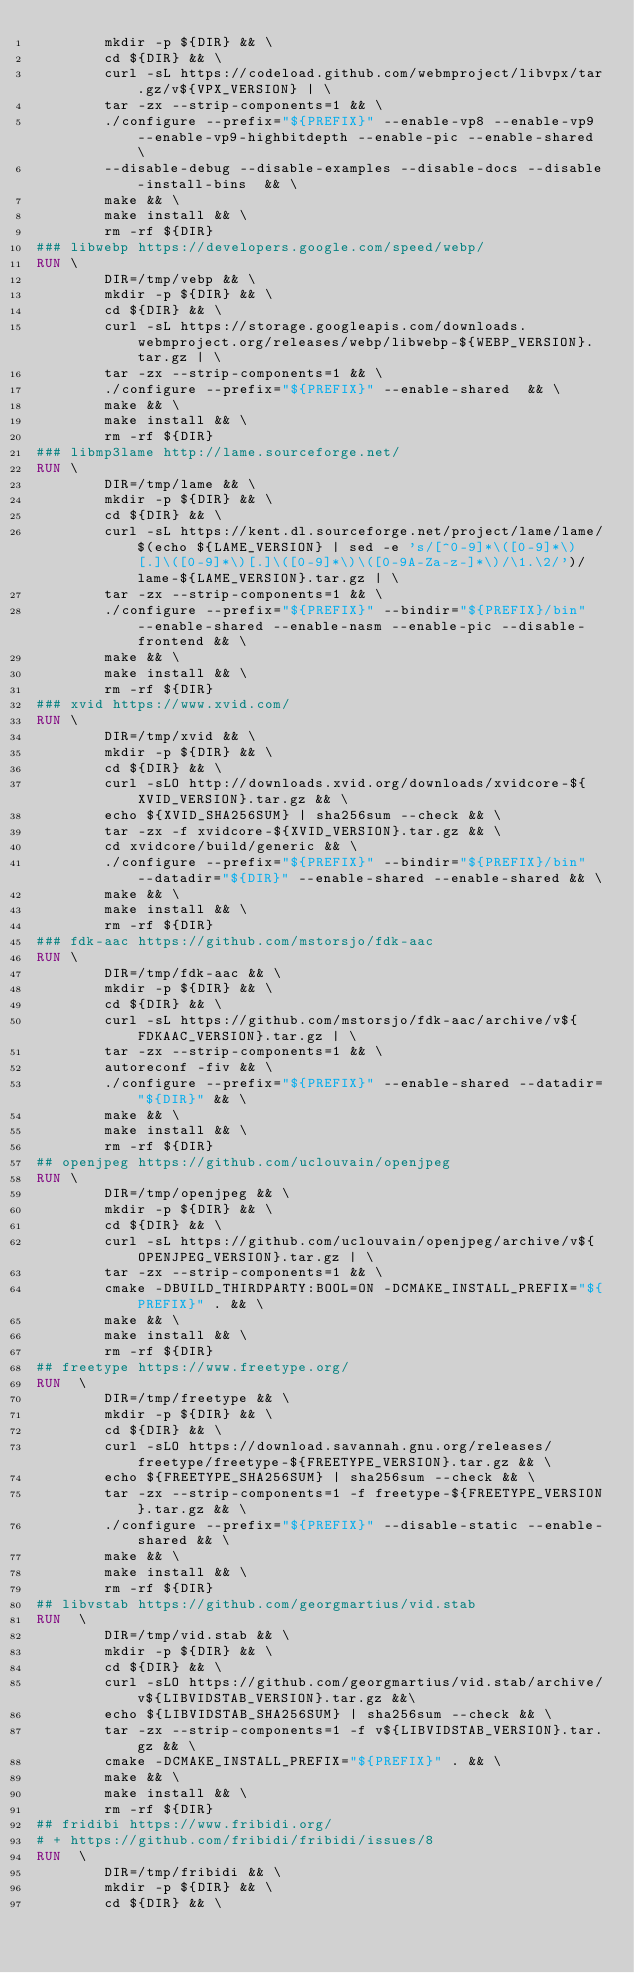<code> <loc_0><loc_0><loc_500><loc_500><_Dockerfile_>        mkdir -p ${DIR} && \
        cd ${DIR} && \
        curl -sL https://codeload.github.com/webmproject/libvpx/tar.gz/v${VPX_VERSION} | \
        tar -zx --strip-components=1 && \
        ./configure --prefix="${PREFIX}" --enable-vp8 --enable-vp9 --enable-vp9-highbitdepth --enable-pic --enable-shared \
        --disable-debug --disable-examples --disable-docs --disable-install-bins  && \
        make && \
        make install && \
        rm -rf ${DIR}
### libwebp https://developers.google.com/speed/webp/
RUN \
        DIR=/tmp/vebp && \
        mkdir -p ${DIR} && \
        cd ${DIR} && \
        curl -sL https://storage.googleapis.com/downloads.webmproject.org/releases/webp/libwebp-${WEBP_VERSION}.tar.gz | \
        tar -zx --strip-components=1 && \
        ./configure --prefix="${PREFIX}" --enable-shared  && \
        make && \
        make install && \
        rm -rf ${DIR}
### libmp3lame http://lame.sourceforge.net/
RUN \
        DIR=/tmp/lame && \
        mkdir -p ${DIR} && \
        cd ${DIR} && \
        curl -sL https://kent.dl.sourceforge.net/project/lame/lame/$(echo ${LAME_VERSION} | sed -e 's/[^0-9]*\([0-9]*\)[.]\([0-9]*\)[.]\([0-9]*\)\([0-9A-Za-z-]*\)/\1.\2/')/lame-${LAME_VERSION}.tar.gz | \
        tar -zx --strip-components=1 && \
        ./configure --prefix="${PREFIX}" --bindir="${PREFIX}/bin" --enable-shared --enable-nasm --enable-pic --disable-frontend && \
        make && \
        make install && \
        rm -rf ${DIR}
### xvid https://www.xvid.com/
RUN \
        DIR=/tmp/xvid && \
        mkdir -p ${DIR} && \
        cd ${DIR} && \
        curl -sLO http://downloads.xvid.org/downloads/xvidcore-${XVID_VERSION}.tar.gz && \
        echo ${XVID_SHA256SUM} | sha256sum --check && \
        tar -zx -f xvidcore-${XVID_VERSION}.tar.gz && \
        cd xvidcore/build/generic && \
        ./configure --prefix="${PREFIX}" --bindir="${PREFIX}/bin" --datadir="${DIR}" --enable-shared --enable-shared && \
        make && \
        make install && \
        rm -rf ${DIR}
### fdk-aac https://github.com/mstorsjo/fdk-aac
RUN \
        DIR=/tmp/fdk-aac && \
        mkdir -p ${DIR} && \
        cd ${DIR} && \
        curl -sL https://github.com/mstorsjo/fdk-aac/archive/v${FDKAAC_VERSION}.tar.gz | \
        tar -zx --strip-components=1 && \
        autoreconf -fiv && \
        ./configure --prefix="${PREFIX}" --enable-shared --datadir="${DIR}" && \
        make && \
        make install && \
        rm -rf ${DIR}
## openjpeg https://github.com/uclouvain/openjpeg
RUN \
        DIR=/tmp/openjpeg && \
        mkdir -p ${DIR} && \
        cd ${DIR} && \
        curl -sL https://github.com/uclouvain/openjpeg/archive/v${OPENJPEG_VERSION}.tar.gz | \
        tar -zx --strip-components=1 && \
        cmake -DBUILD_THIRDPARTY:BOOL=ON -DCMAKE_INSTALL_PREFIX="${PREFIX}" . && \
        make && \
        make install && \
        rm -rf ${DIR}
## freetype https://www.freetype.org/
RUN  \
        DIR=/tmp/freetype && \
        mkdir -p ${DIR} && \
        cd ${DIR} && \
        curl -sLO https://download.savannah.gnu.org/releases/freetype/freetype-${FREETYPE_VERSION}.tar.gz && \
        echo ${FREETYPE_SHA256SUM} | sha256sum --check && \
        tar -zx --strip-components=1 -f freetype-${FREETYPE_VERSION}.tar.gz && \
        ./configure --prefix="${PREFIX}" --disable-static --enable-shared && \
        make && \
        make install && \
        rm -rf ${DIR}
## libvstab https://github.com/georgmartius/vid.stab
RUN  \
        DIR=/tmp/vid.stab && \
        mkdir -p ${DIR} && \
        cd ${DIR} && \
        curl -sLO https://github.com/georgmartius/vid.stab/archive/v${LIBVIDSTAB_VERSION}.tar.gz &&\
        echo ${LIBVIDSTAB_SHA256SUM} | sha256sum --check && \
        tar -zx --strip-components=1 -f v${LIBVIDSTAB_VERSION}.tar.gz && \
        cmake -DCMAKE_INSTALL_PREFIX="${PREFIX}" . && \
        make && \
        make install && \
        rm -rf ${DIR}
## fridibi https://www.fribidi.org/
# + https://github.com/fribidi/fribidi/issues/8
RUN  \
        DIR=/tmp/fribidi && \
        mkdir -p ${DIR} && \
        cd ${DIR} && \</code> 